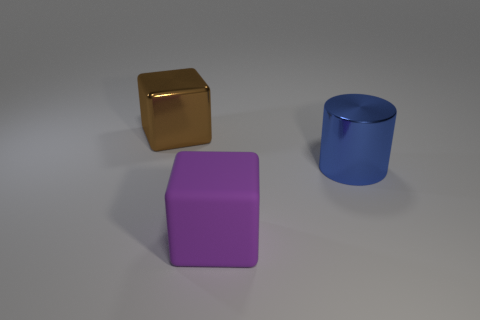What number of blue cylinders are behind the large blue cylinder?
Give a very brief answer. 0. What number of large blue objects are there?
Give a very brief answer. 1. Does the blue metal cylinder have the same size as the purple rubber thing?
Provide a succinct answer. Yes. Is there a big cube that is to the left of the metal object that is on the left side of the cube in front of the cylinder?
Offer a terse response. No. What is the material of the other big thing that is the same shape as the big purple object?
Keep it short and to the point. Metal. What color is the object that is in front of the large blue metallic thing?
Make the answer very short. Purple. The matte object is what size?
Make the answer very short. Large. There is a blue object; does it have the same size as the purple block that is in front of the large blue metallic object?
Keep it short and to the point. Yes. There is a shiny object to the left of the cube that is to the right of the large block behind the blue thing; what color is it?
Your response must be concise. Brown. Do the thing that is to the right of the large matte cube and the brown object have the same material?
Provide a short and direct response. Yes. 